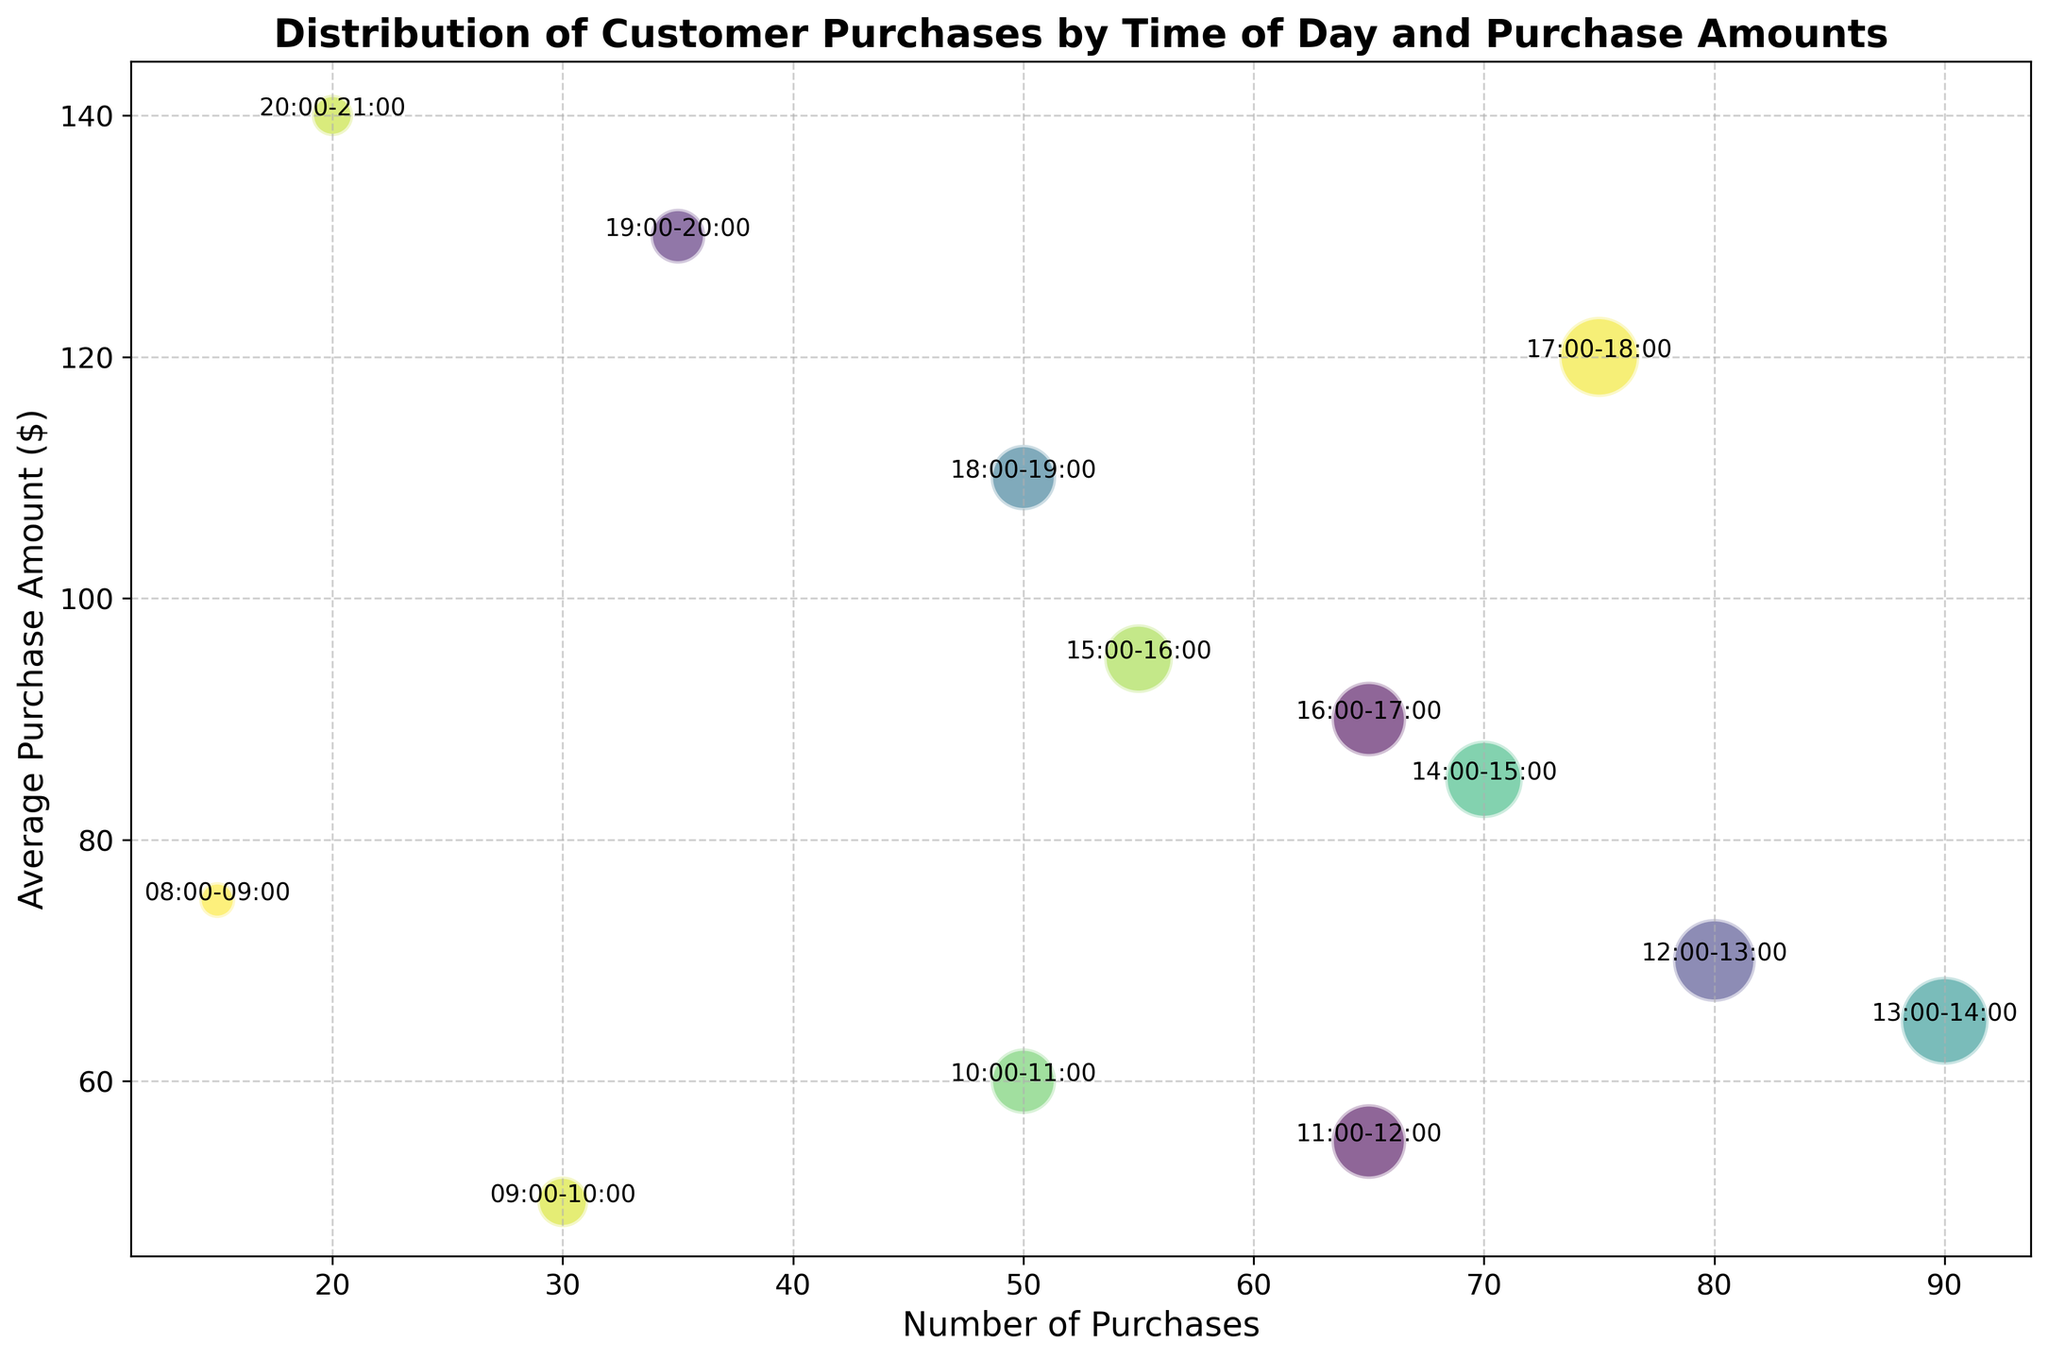Which time period has the highest average purchase amount? To determine the time period with the highest average purchase amount, look for the bubble with the highest position along the "Average Purchase Amount" axis. In this case, the 20:00-21:00 period has the highest average purchase amount.
Answer: 20:00-21:00 Which time period has the most number of purchases? To find the time period with the most purchases, look for the bubble with the largest size. The size of the bubbles represents the number of purchases, and the largest bubble is for the 13:00-14:00 period.
Answer: 13:00-14:00 During which time period is the average purchase amount the lowest? To identify the time period with the lowest average purchase amount, look for the bubble with the lowest position along the "Average Purchase Amount" axis. The period 09:00-10:00 has the lowest average purchase amount.
Answer: 09:00-10:00 Compare the number of purchases between 12:00-13:00 and 15:00-16:00. Which is greater and by how much? To compare these time periods, look at the size of the bubbles. 12:00-13:00 has 80 purchases and 15:00-16:00 has 55 purchases. The difference is 80 - 55 = 25.
Answer: 12:00-13:00 by 25 What is the average purchase amount for bubbles with more than 50 purchases? To find the average purchase amount for bubbles with more than 50 purchases, first identify the relevant time periods: 10:00-11:00 (60), 11:00-12:00 (55), 12:00-13:00 (70), 13:00-14:00 (65), 14:00-15:00 (85), 16:00-17:00 (90), and 17:00-18:00 (120). Average these amounts: (60 + 55 + 70 + 65 + 85 + 90 + 120) / 7 ≈ 77.9.
Answer: 77.9 Which time periods have an average purchase amount greater than 100 dollars? To find these periods, look for bubbles positioned above the 100 mark on the "Average Purchase Amount" axis. The periods are 17:00-18:00, 18:00-19:00, and 19:00-20:00, and 20:00-21:00.
Answer: 17:00-18:00, 18:00-19:00, 19:00-20:00, and 20:00-21:00 Between 14:00-15:00 and 16:00-17:00, which period has a higher average purchase amount? Compare the positions of the bubbles for the 14:00-15:00 and 16:00-17:00 periods along the "Average Purchase Amount" axis. The 16:00-17:00 period is higher at 90, compared to 14:00-15:00 at 85.
Answer: 16:00-17:00 How does the number of purchases at 18:00-19:00 compare to that at 13:00-14:00? Compare the sizes of the bubbles for 18:00-19:00 (50 purchases) and 13:00-14:00 (90 purchases). 13:00-14:00 has more purchases.
Answer: 13:00-14:00 has more What is the total number of purchases between 08:00-12:00? Sum the number of purchases from 08:00-09:00 (15), 09:00-10:00 (30), 10:00-11:00 (50), and 11:00-12:00 (65): 15 + 30 + 50 + 65 = 160.
Answer: 160 Which time period has an average purchase amount closest to 100 dollars? Look for the bubble nearest to the $100 mark on the "Average Purchase Amount" axis. The 16:00-17:00 period is closest with an average purchase amount of 90 dollars.
Answer: 16:00-17:00 